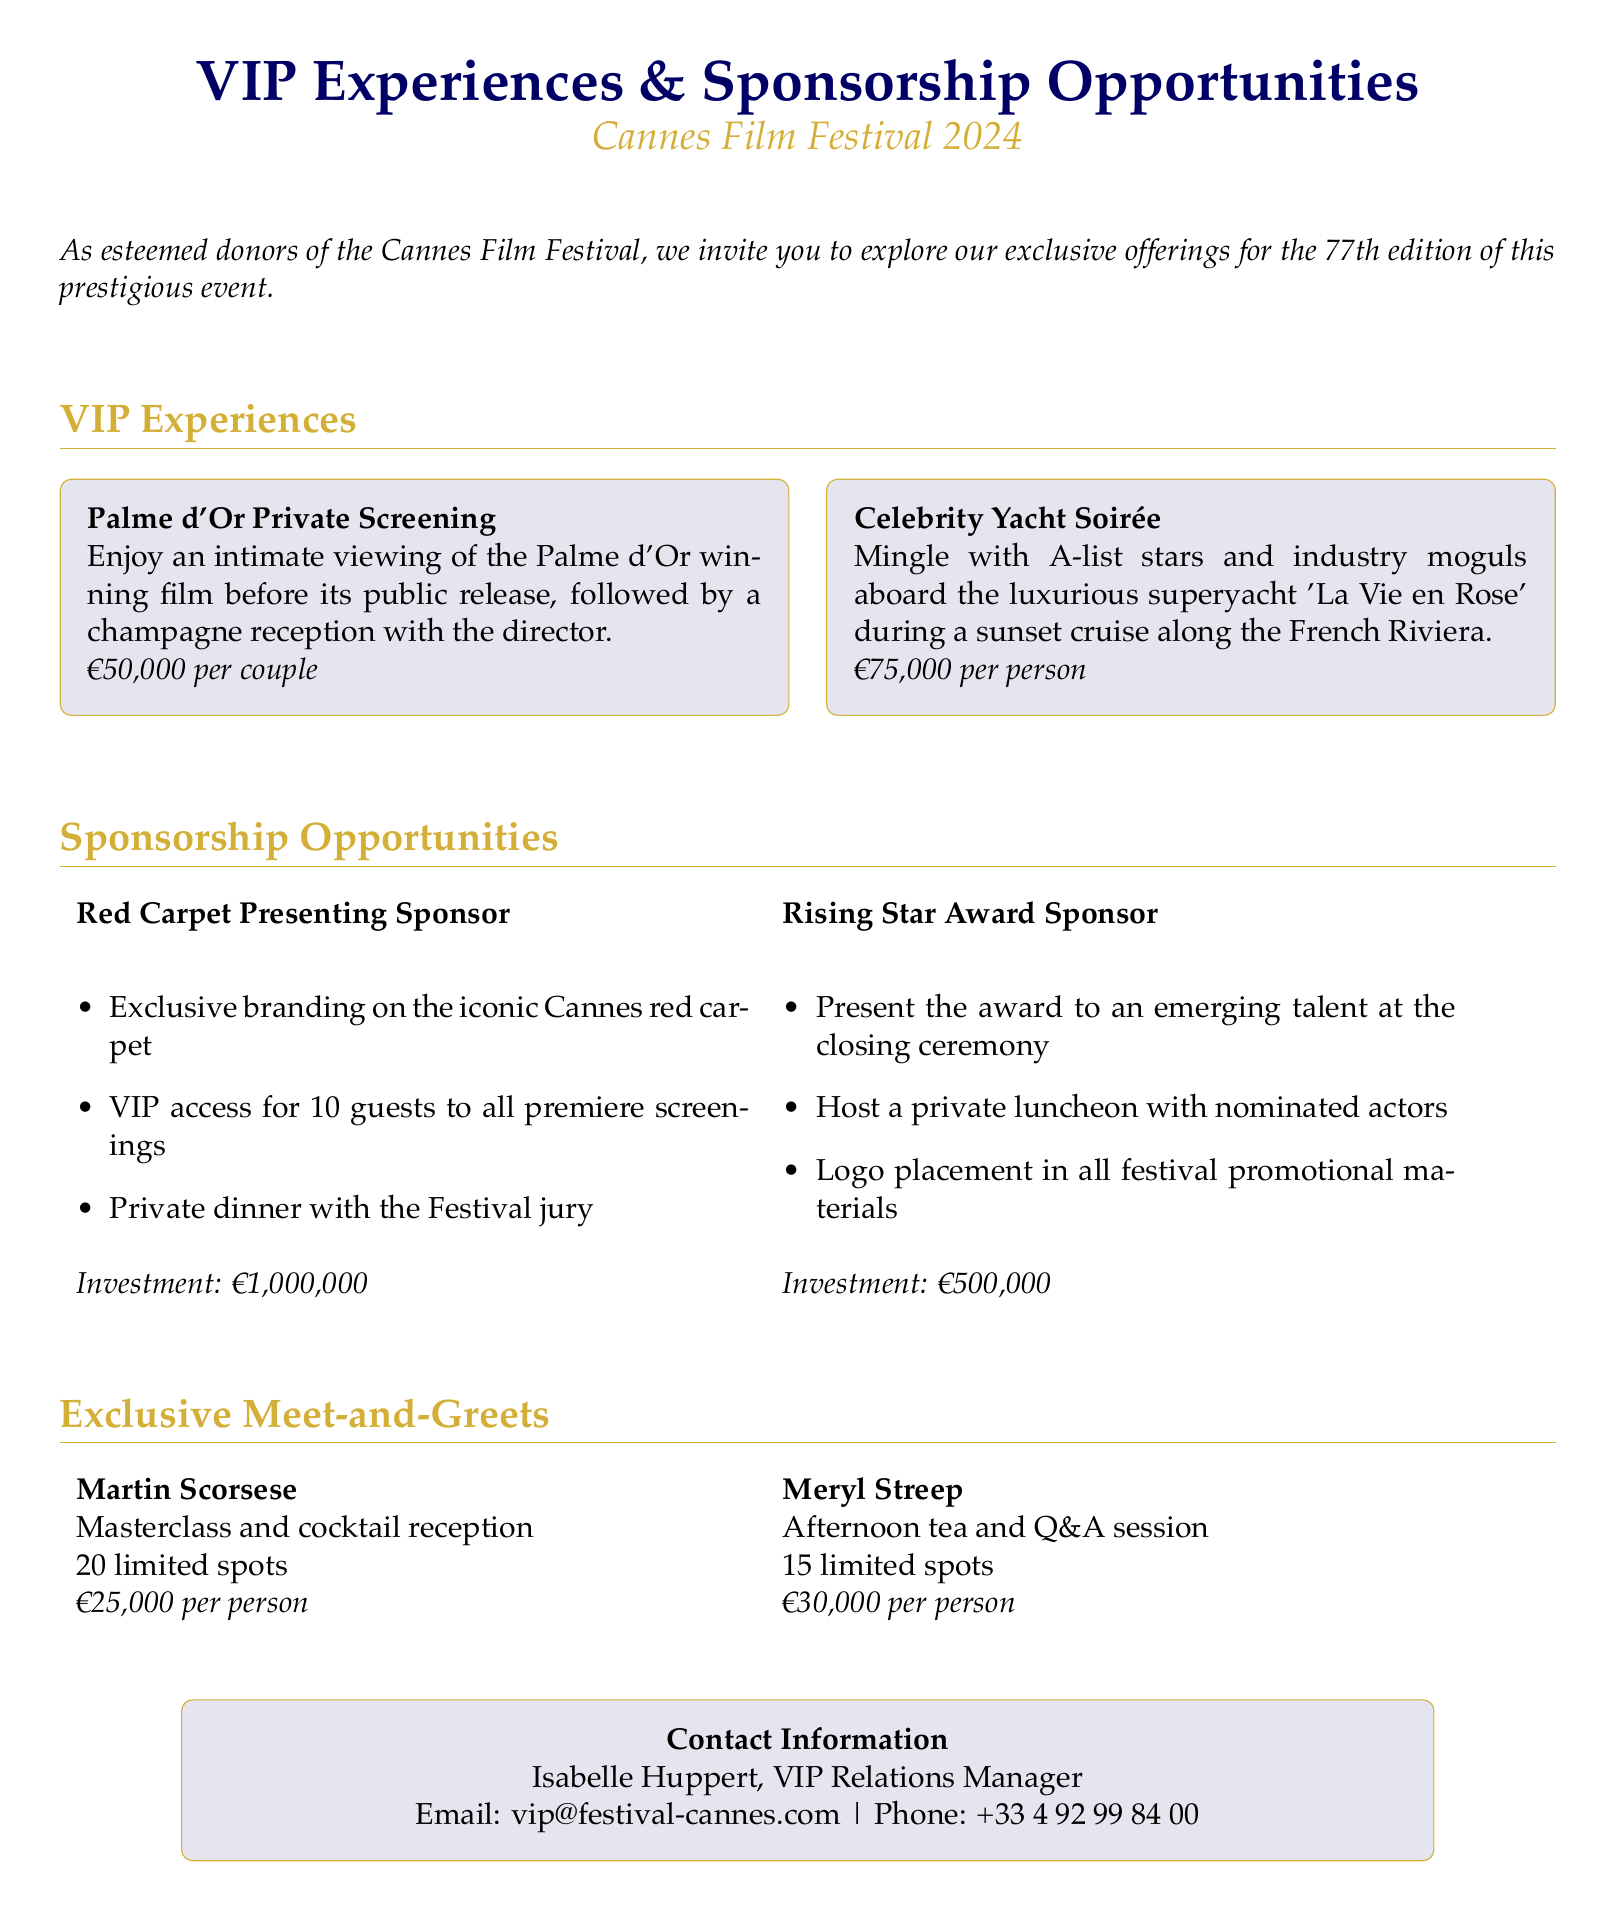What is the price for the Palme d'Or Private Screening? The document states the price for the Palme d'Or Private Screening is €50,000 per couple.
Answer: €50,000 per couple How many guests receive VIP access with the Red Carpet Presenting Sponsor opportunity? The Red Carpet Presenting Sponsor opportunity includes VIP access for 10 guests to all premiere screenings.
Answer: 10 guests What is the investment amount required for the Rising Star Award Sponsor? The document indicates that the investment for the Rising Star Award Sponsor is €500,000.
Answer: €500,000 Who is the VIP Relations Manager listed in the contact information? The contact section of the document lists Isabelle Huppert as the VIP Relations Manager.
Answer: Isabelle Huppert How many limited spots are available for the Martin Scorsese meet-and-greet? The Martin Scorsese meet-and-greet has 20 limited spots available.
Answer: 20 limited spots What type of event is the Celebrity Yacht Soirée? The Celebrity Yacht Soirée is described as a mingling event with A-list stars and industry moguls aboard a luxurious superyacht.
Answer: Mingling event What unique offering follows the Palme d'Or screening? Following the Palme d'Or screening, there is a champagne reception with the director.
Answer: Champagne reception What kind of session is Meryl Streep's meet-and-greet? The Meryl Streep meet-and-greet is structured as an afternoon tea and Q&A session.
Answer: Afternoon tea and Q&A session 